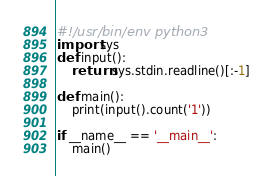<code> <loc_0><loc_0><loc_500><loc_500><_Python_>#!/usr/bin/env python3
import sys
def input():
    return sys.stdin.readline()[:-1]

def main():
    print(input().count('1'))

if __name__ == '__main__':
    main()
</code> 